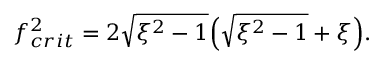Convert formula to latex. <formula><loc_0><loc_0><loc_500><loc_500>f _ { c r i t } ^ { 2 } = 2 \sqrt { \xi ^ { 2 } - 1 } \left ( \sqrt { \xi ^ { 2 } - 1 } + \xi \right ) .</formula> 